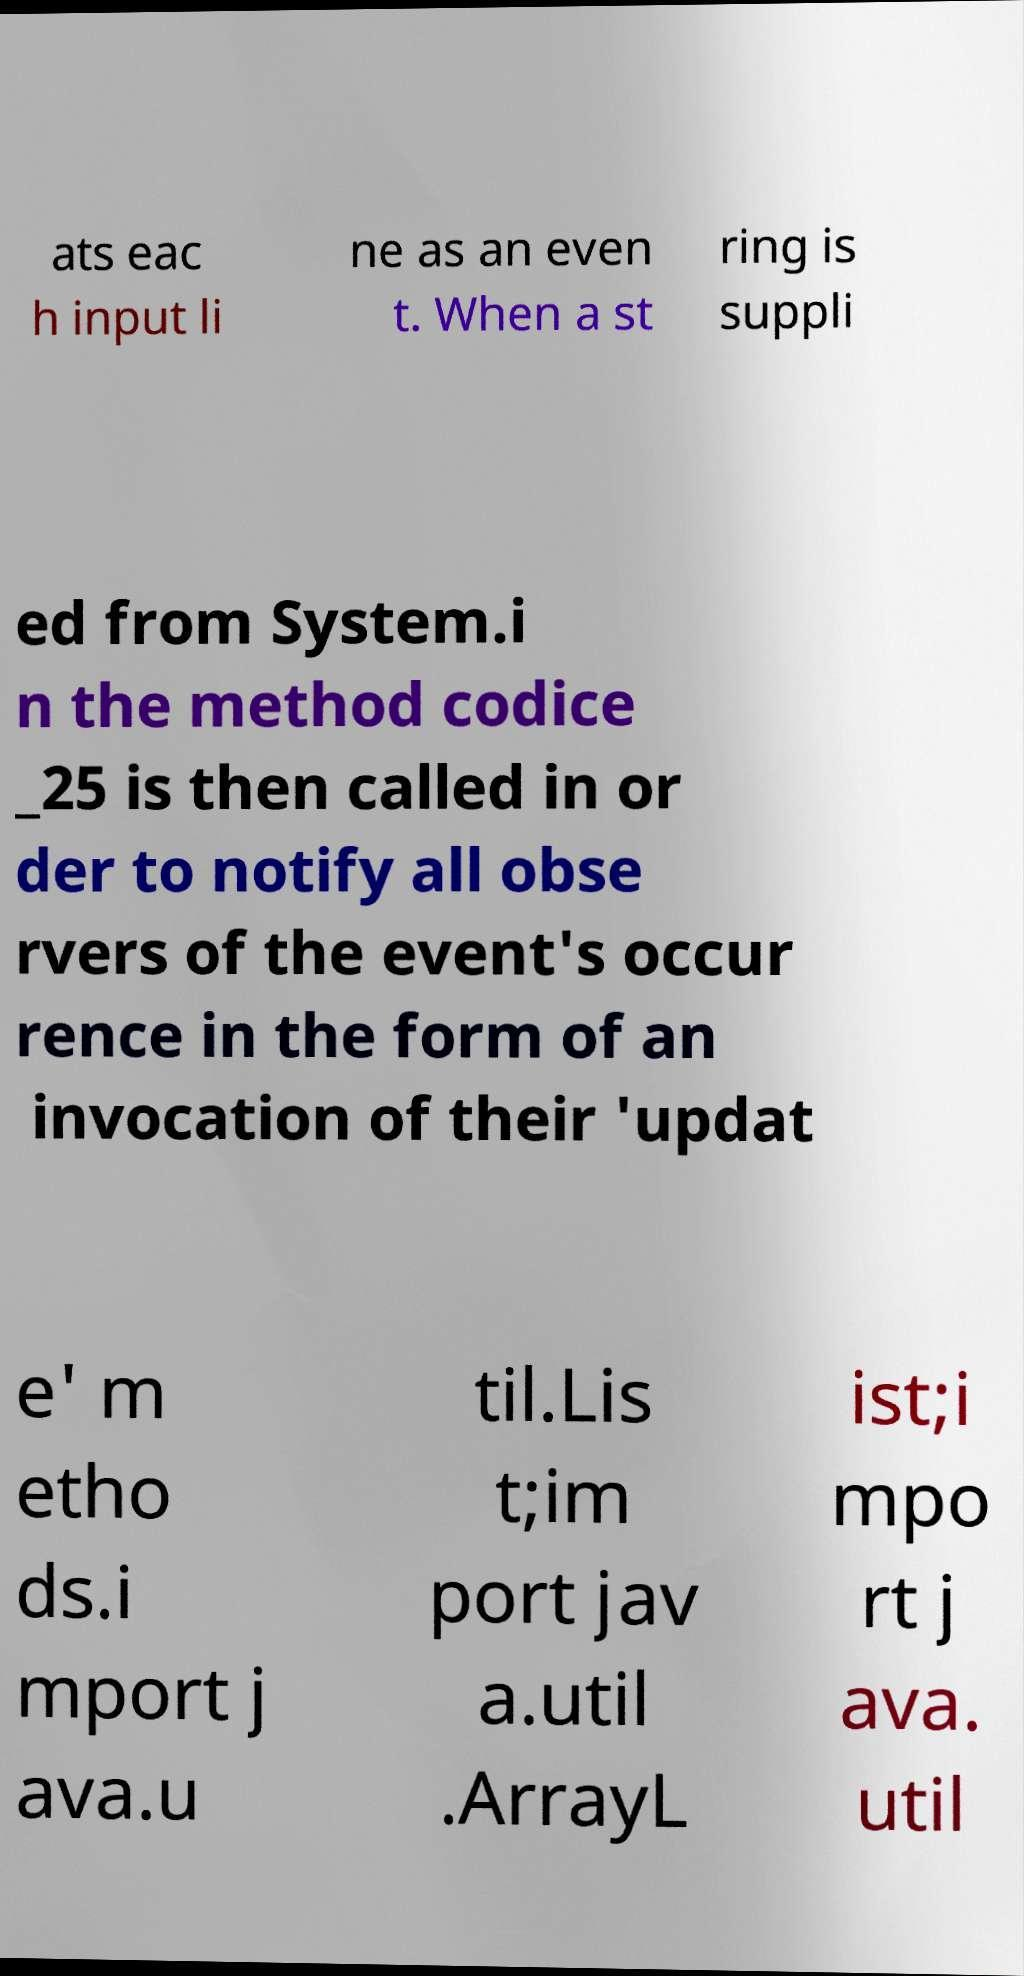What messages or text are displayed in this image? I need them in a readable, typed format. ats eac h input li ne as an even t. When a st ring is suppli ed from System.i n the method codice _25 is then called in or der to notify all obse rvers of the event's occur rence in the form of an invocation of their 'updat e' m etho ds.i mport j ava.u til.Lis t;im port jav a.util .ArrayL ist;i mpo rt j ava. util 